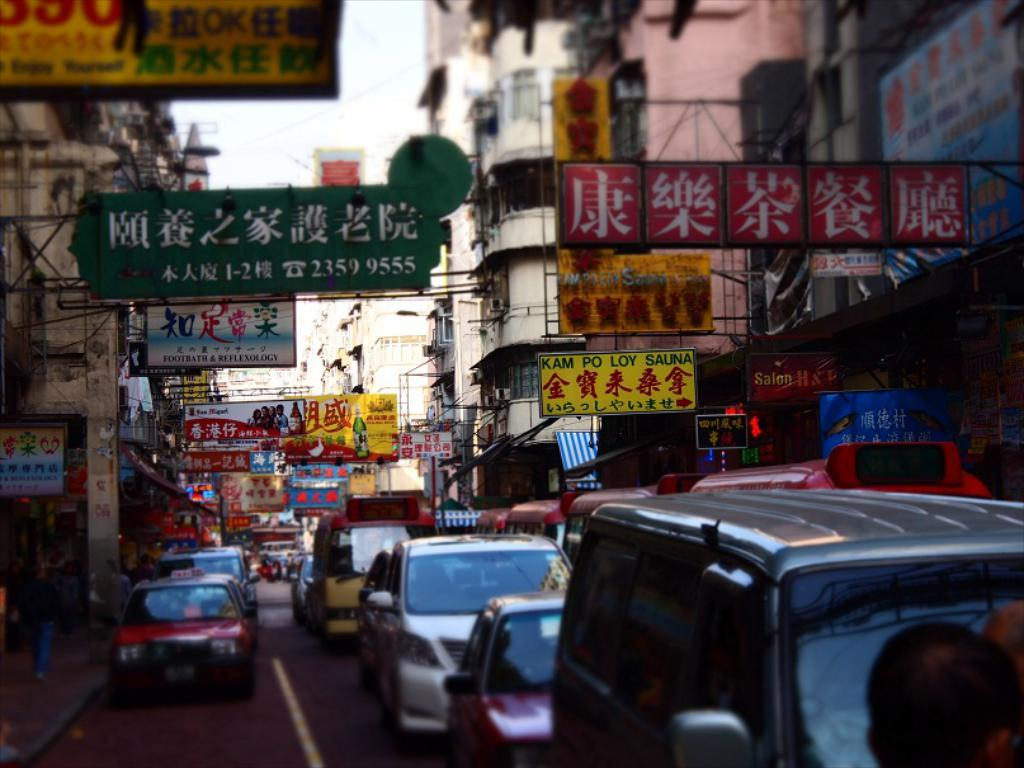<image>
Create a compact narrative representing the image presented. The yellow sign to the right advertises Kam Po Loy Sauna. 